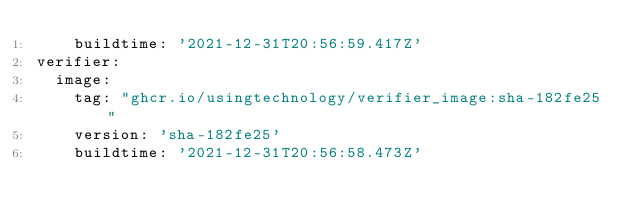Convert code to text. <code><loc_0><loc_0><loc_500><loc_500><_YAML_>    buildtime: '2021-12-31T20:56:59.417Z'
verifier:
  image:
    tag: "ghcr.io/usingtechnology/verifier_image:sha-182fe25"
    version: 'sha-182fe25'
    buildtime: '2021-12-31T20:56:58.473Z'
</code> 